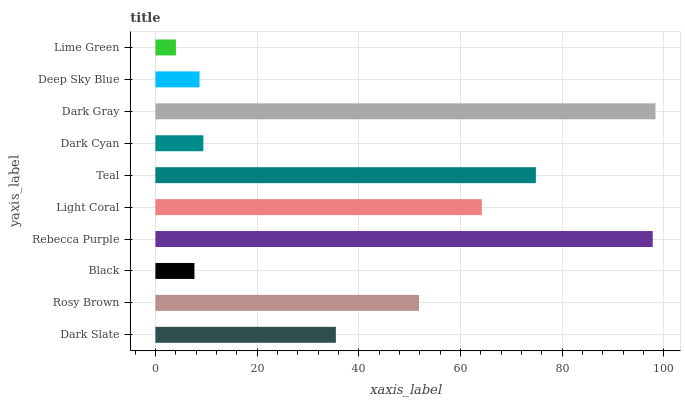Is Lime Green the minimum?
Answer yes or no. Yes. Is Dark Gray the maximum?
Answer yes or no. Yes. Is Rosy Brown the minimum?
Answer yes or no. No. Is Rosy Brown the maximum?
Answer yes or no. No. Is Rosy Brown greater than Dark Slate?
Answer yes or no. Yes. Is Dark Slate less than Rosy Brown?
Answer yes or no. Yes. Is Dark Slate greater than Rosy Brown?
Answer yes or no. No. Is Rosy Brown less than Dark Slate?
Answer yes or no. No. Is Rosy Brown the high median?
Answer yes or no. Yes. Is Dark Slate the low median?
Answer yes or no. Yes. Is Black the high median?
Answer yes or no. No. Is Light Coral the low median?
Answer yes or no. No. 